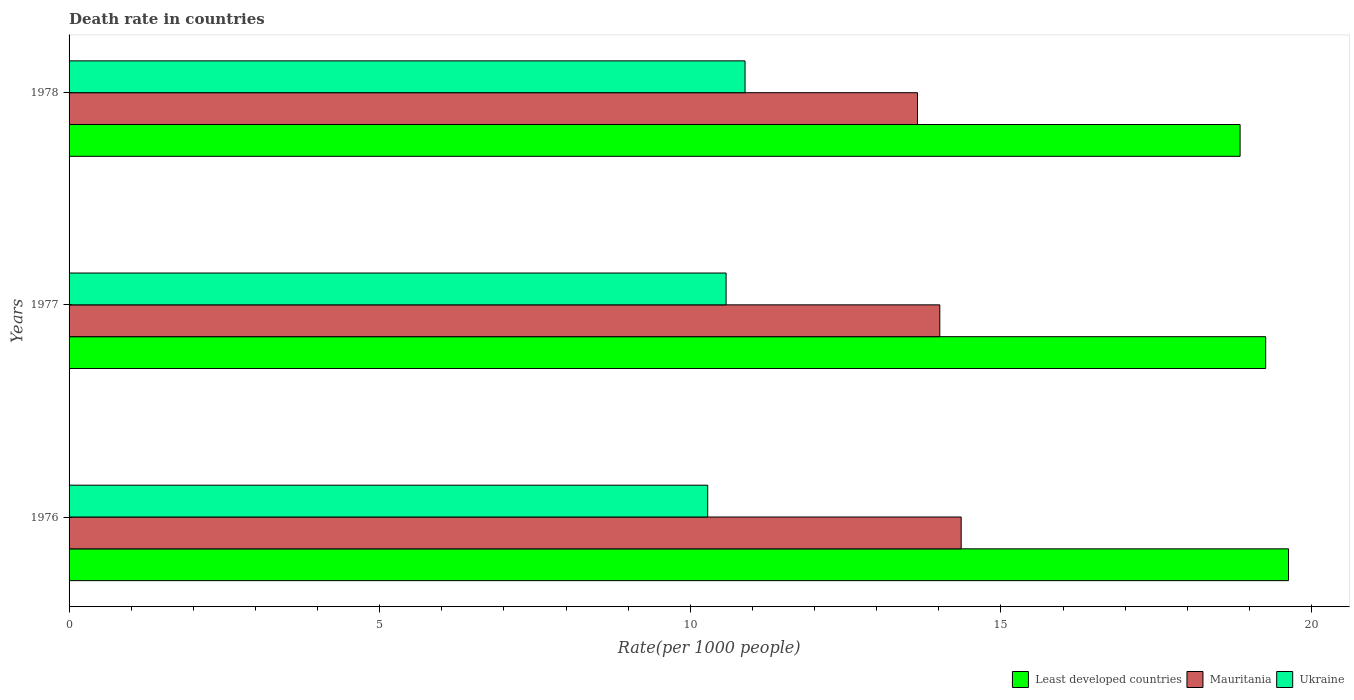How many different coloured bars are there?
Provide a succinct answer. 3. How many groups of bars are there?
Offer a terse response. 3. Are the number of bars per tick equal to the number of legend labels?
Offer a terse response. Yes. Are the number of bars on each tick of the Y-axis equal?
Your answer should be compact. Yes. How many bars are there on the 2nd tick from the bottom?
Your answer should be compact. 3. What is the label of the 3rd group of bars from the top?
Provide a short and direct response. 1976. In how many cases, is the number of bars for a given year not equal to the number of legend labels?
Offer a very short reply. 0. What is the death rate in Least developed countries in 1978?
Offer a very short reply. 18.85. Across all years, what is the maximum death rate in Least developed countries?
Give a very brief answer. 19.63. Across all years, what is the minimum death rate in Mauritania?
Your response must be concise. 13.66. In which year was the death rate in Mauritania maximum?
Make the answer very short. 1976. In which year was the death rate in Ukraine minimum?
Provide a succinct answer. 1976. What is the total death rate in Mauritania in the graph?
Provide a short and direct response. 42.03. What is the difference between the death rate in Mauritania in 1976 and that in 1978?
Provide a short and direct response. 0.7. What is the difference between the death rate in Least developed countries in 1978 and the death rate in Mauritania in 1977?
Keep it short and to the point. 4.83. What is the average death rate in Mauritania per year?
Offer a very short reply. 14.01. In the year 1977, what is the difference between the death rate in Ukraine and death rate in Least developed countries?
Your response must be concise. -8.69. What is the ratio of the death rate in Least developed countries in 1976 to that in 1977?
Your answer should be compact. 1.02. What is the difference between the highest and the second highest death rate in Ukraine?
Your answer should be compact. 0.3. What is the difference between the highest and the lowest death rate in Ukraine?
Make the answer very short. 0.6. Is the sum of the death rate in Least developed countries in 1976 and 1978 greater than the maximum death rate in Ukraine across all years?
Keep it short and to the point. Yes. What does the 3rd bar from the top in 1977 represents?
Make the answer very short. Least developed countries. What does the 1st bar from the bottom in 1978 represents?
Ensure brevity in your answer.  Least developed countries. Is it the case that in every year, the sum of the death rate in Ukraine and death rate in Least developed countries is greater than the death rate in Mauritania?
Keep it short and to the point. Yes. Are all the bars in the graph horizontal?
Provide a short and direct response. Yes. How many years are there in the graph?
Provide a succinct answer. 3. Are the values on the major ticks of X-axis written in scientific E-notation?
Offer a terse response. No. Does the graph contain any zero values?
Your answer should be compact. No. Where does the legend appear in the graph?
Keep it short and to the point. Bottom right. What is the title of the graph?
Ensure brevity in your answer.  Death rate in countries. Does "Canada" appear as one of the legend labels in the graph?
Offer a very short reply. No. What is the label or title of the X-axis?
Offer a terse response. Rate(per 1000 people). What is the Rate(per 1000 people) in Least developed countries in 1976?
Your answer should be compact. 19.63. What is the Rate(per 1000 people) of Mauritania in 1976?
Ensure brevity in your answer.  14.36. What is the Rate(per 1000 people) in Ukraine in 1976?
Provide a short and direct response. 10.28. What is the Rate(per 1000 people) of Least developed countries in 1977?
Keep it short and to the point. 19.26. What is the Rate(per 1000 people) of Mauritania in 1977?
Offer a terse response. 14.02. What is the Rate(per 1000 people) in Ukraine in 1977?
Provide a short and direct response. 10.58. What is the Rate(per 1000 people) of Least developed countries in 1978?
Your answer should be compact. 18.85. What is the Rate(per 1000 people) of Mauritania in 1978?
Ensure brevity in your answer.  13.66. What is the Rate(per 1000 people) in Ukraine in 1978?
Provide a succinct answer. 10.88. Across all years, what is the maximum Rate(per 1000 people) in Least developed countries?
Give a very brief answer. 19.63. Across all years, what is the maximum Rate(per 1000 people) in Mauritania?
Offer a terse response. 14.36. Across all years, what is the maximum Rate(per 1000 people) in Ukraine?
Provide a short and direct response. 10.88. Across all years, what is the minimum Rate(per 1000 people) in Least developed countries?
Offer a terse response. 18.85. Across all years, what is the minimum Rate(per 1000 people) of Mauritania?
Your answer should be compact. 13.66. Across all years, what is the minimum Rate(per 1000 people) of Ukraine?
Keep it short and to the point. 10.28. What is the total Rate(per 1000 people) of Least developed countries in the graph?
Provide a short and direct response. 57.74. What is the total Rate(per 1000 people) of Mauritania in the graph?
Your answer should be compact. 42.03. What is the total Rate(per 1000 people) of Ukraine in the graph?
Offer a terse response. 31.74. What is the difference between the Rate(per 1000 people) in Least developed countries in 1976 and that in 1977?
Your answer should be compact. 0.37. What is the difference between the Rate(per 1000 people) in Mauritania in 1976 and that in 1977?
Make the answer very short. 0.34. What is the difference between the Rate(per 1000 people) of Ukraine in 1976 and that in 1977?
Offer a very short reply. -0.3. What is the difference between the Rate(per 1000 people) of Least developed countries in 1976 and that in 1978?
Offer a terse response. 0.78. What is the difference between the Rate(per 1000 people) in Mauritania in 1976 and that in 1978?
Your answer should be compact. 0.7. What is the difference between the Rate(per 1000 people) of Ukraine in 1976 and that in 1978?
Your response must be concise. -0.6. What is the difference between the Rate(per 1000 people) in Least developed countries in 1977 and that in 1978?
Your answer should be very brief. 0.41. What is the difference between the Rate(per 1000 people) in Mauritania in 1977 and that in 1978?
Give a very brief answer. 0.36. What is the difference between the Rate(per 1000 people) in Ukraine in 1977 and that in 1978?
Make the answer very short. -0.3. What is the difference between the Rate(per 1000 people) of Least developed countries in 1976 and the Rate(per 1000 people) of Mauritania in 1977?
Provide a succinct answer. 5.61. What is the difference between the Rate(per 1000 people) in Least developed countries in 1976 and the Rate(per 1000 people) in Ukraine in 1977?
Give a very brief answer. 9.05. What is the difference between the Rate(per 1000 people) of Mauritania in 1976 and the Rate(per 1000 people) of Ukraine in 1977?
Your response must be concise. 3.78. What is the difference between the Rate(per 1000 people) in Least developed countries in 1976 and the Rate(per 1000 people) in Mauritania in 1978?
Keep it short and to the point. 5.97. What is the difference between the Rate(per 1000 people) in Least developed countries in 1976 and the Rate(per 1000 people) in Ukraine in 1978?
Offer a very short reply. 8.75. What is the difference between the Rate(per 1000 people) of Mauritania in 1976 and the Rate(per 1000 people) of Ukraine in 1978?
Give a very brief answer. 3.48. What is the difference between the Rate(per 1000 people) in Least developed countries in 1977 and the Rate(per 1000 people) in Mauritania in 1978?
Make the answer very short. 5.6. What is the difference between the Rate(per 1000 people) of Least developed countries in 1977 and the Rate(per 1000 people) of Ukraine in 1978?
Offer a very short reply. 8.38. What is the difference between the Rate(per 1000 people) of Mauritania in 1977 and the Rate(per 1000 people) of Ukraine in 1978?
Offer a terse response. 3.13. What is the average Rate(per 1000 people) of Least developed countries per year?
Keep it short and to the point. 19.25. What is the average Rate(per 1000 people) of Mauritania per year?
Make the answer very short. 14.01. What is the average Rate(per 1000 people) in Ukraine per year?
Offer a terse response. 10.58. In the year 1976, what is the difference between the Rate(per 1000 people) in Least developed countries and Rate(per 1000 people) in Mauritania?
Your answer should be compact. 5.27. In the year 1976, what is the difference between the Rate(per 1000 people) in Least developed countries and Rate(per 1000 people) in Ukraine?
Offer a terse response. 9.35. In the year 1976, what is the difference between the Rate(per 1000 people) in Mauritania and Rate(per 1000 people) in Ukraine?
Make the answer very short. 4.08. In the year 1977, what is the difference between the Rate(per 1000 people) of Least developed countries and Rate(per 1000 people) of Mauritania?
Offer a terse response. 5.25. In the year 1977, what is the difference between the Rate(per 1000 people) in Least developed countries and Rate(per 1000 people) in Ukraine?
Give a very brief answer. 8.69. In the year 1977, what is the difference between the Rate(per 1000 people) of Mauritania and Rate(per 1000 people) of Ukraine?
Offer a terse response. 3.44. In the year 1978, what is the difference between the Rate(per 1000 people) in Least developed countries and Rate(per 1000 people) in Mauritania?
Your response must be concise. 5.19. In the year 1978, what is the difference between the Rate(per 1000 people) in Least developed countries and Rate(per 1000 people) in Ukraine?
Keep it short and to the point. 7.97. In the year 1978, what is the difference between the Rate(per 1000 people) of Mauritania and Rate(per 1000 people) of Ukraine?
Your response must be concise. 2.78. What is the ratio of the Rate(per 1000 people) of Least developed countries in 1976 to that in 1977?
Keep it short and to the point. 1.02. What is the ratio of the Rate(per 1000 people) of Mauritania in 1976 to that in 1977?
Offer a terse response. 1.02. What is the ratio of the Rate(per 1000 people) of Ukraine in 1976 to that in 1977?
Provide a succinct answer. 0.97. What is the ratio of the Rate(per 1000 people) of Least developed countries in 1976 to that in 1978?
Provide a succinct answer. 1.04. What is the ratio of the Rate(per 1000 people) of Mauritania in 1976 to that in 1978?
Offer a terse response. 1.05. What is the ratio of the Rate(per 1000 people) of Ukraine in 1976 to that in 1978?
Offer a terse response. 0.94. What is the ratio of the Rate(per 1000 people) in Least developed countries in 1977 to that in 1978?
Offer a terse response. 1.02. What is the ratio of the Rate(per 1000 people) of Mauritania in 1977 to that in 1978?
Your answer should be very brief. 1.03. What is the difference between the highest and the second highest Rate(per 1000 people) in Least developed countries?
Offer a very short reply. 0.37. What is the difference between the highest and the second highest Rate(per 1000 people) in Mauritania?
Your response must be concise. 0.34. What is the difference between the highest and the second highest Rate(per 1000 people) of Ukraine?
Make the answer very short. 0.3. What is the difference between the highest and the lowest Rate(per 1000 people) in Least developed countries?
Ensure brevity in your answer.  0.78. What is the difference between the highest and the lowest Rate(per 1000 people) in Mauritania?
Your answer should be very brief. 0.7. What is the difference between the highest and the lowest Rate(per 1000 people) in Ukraine?
Provide a short and direct response. 0.6. 